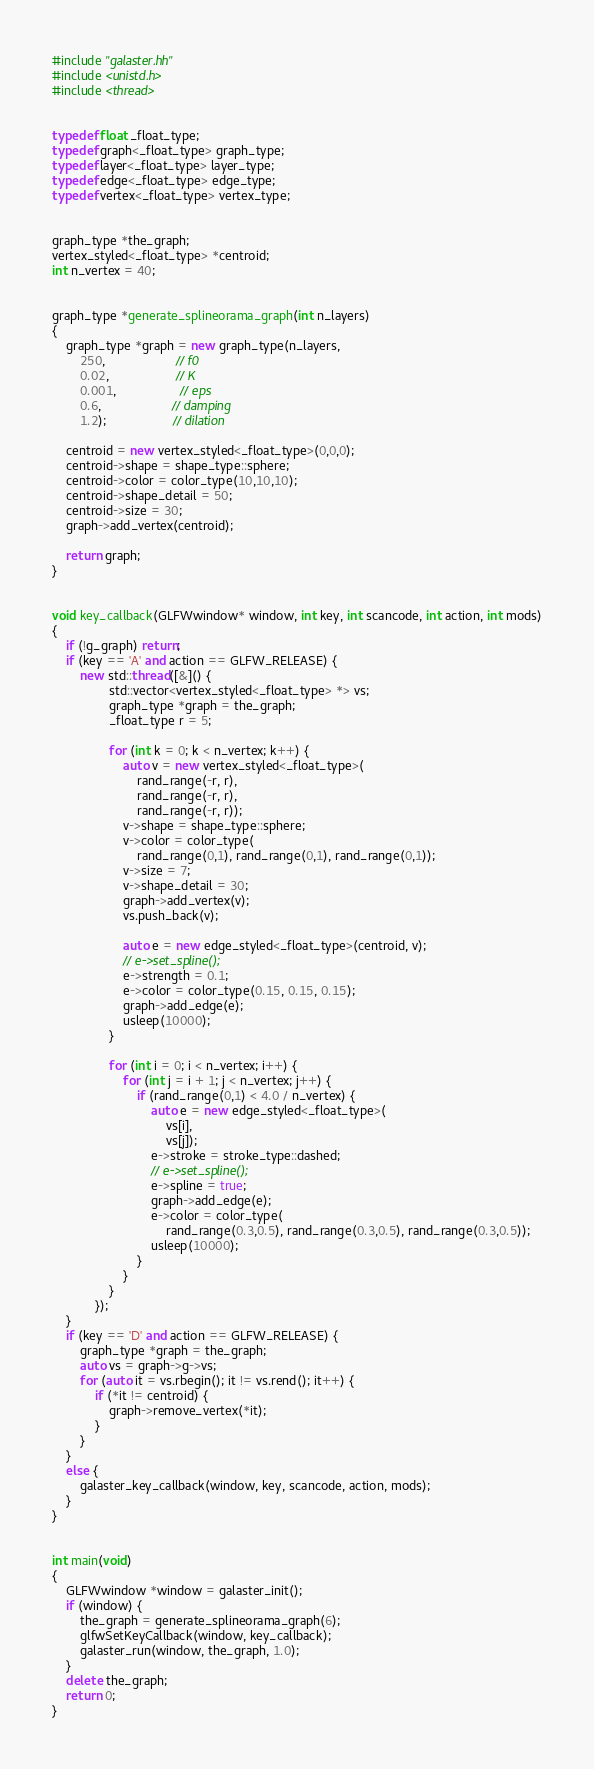<code> <loc_0><loc_0><loc_500><loc_500><_C++_>#include "galaster.hh"
#include <unistd.h>
#include <thread>


typedef float _float_type;
typedef graph<_float_type> graph_type;
typedef layer<_float_type> layer_type;
typedef edge<_float_type> edge_type;
typedef vertex<_float_type> vertex_type;


graph_type *the_graph;
vertex_styled<_float_type> *centroid;
int n_vertex = 40;


graph_type *generate_splineorama_graph(int n_layers)
{
    graph_type *graph = new graph_type(n_layers, 
        250,                    // f0
        0.02,                   // K
        0.001,                  // eps
        0.6,                    // damping
        1.2);                   // dilation

    centroid = new vertex_styled<_float_type>(0,0,0);
    centroid->shape = shape_type::sphere;
    centroid->color = color_type(10,10,10);
    centroid->shape_detail = 50;
    centroid->size = 30;
    graph->add_vertex(centroid);
    
    return graph;
}


void key_callback(GLFWwindow* window, int key, int scancode, int action, int mods)
{
    if (!g_graph) return;
    if (key == 'A' and action == GLFW_RELEASE) {
        new std::thread([&]() {
                std::vector<vertex_styled<_float_type> *> vs;
                graph_type *graph = the_graph;
                _float_type r = 5;

                for (int k = 0; k < n_vertex; k++) {
                    auto v = new vertex_styled<_float_type>(
                        rand_range(-r, r),
                        rand_range(-r, r),
                        rand_range(-r, r));
                    v->shape = shape_type::sphere;
                    v->color = color_type(
                        rand_range(0,1), rand_range(0,1), rand_range(0,1));
                    v->size = 7;
                    v->shape_detail = 30;
                    graph->add_vertex(v);
                    vs.push_back(v);

                    auto e = new edge_styled<_float_type>(centroid, v);
                    // e->set_spline();
                    e->strength = 0.1;
                    e->color = color_type(0.15, 0.15, 0.15);
                    graph->add_edge(e);
                    usleep(10000);
                }

                for (int i = 0; i < n_vertex; i++) {
                    for (int j = i + 1; j < n_vertex; j++) {
                        if (rand_range(0,1) < 4.0 / n_vertex) {
                            auto e = new edge_styled<_float_type>(
                                vs[i],
                                vs[j]);
                            e->stroke = stroke_type::dashed;
                            // e->set_spline();
                            e->spline = true;
                            graph->add_edge(e);
                            e->color = color_type(
                                rand_range(0.3,0.5), rand_range(0.3,0.5), rand_range(0.3,0.5));
                            usleep(10000);
                        }
                    }
                }
            });
    }
    if (key == 'D' and action == GLFW_RELEASE) {
        graph_type *graph = the_graph;
        auto vs = graph->g->vs;
        for (auto it = vs.rbegin(); it != vs.rend(); it++) {
            if (*it != centroid) {
                graph->remove_vertex(*it);
            }
        }
    }
    else {
        galaster_key_callback(window, key, scancode, action, mods);
    }
}


int main(void)
{
    GLFWwindow *window = galaster_init();
    if (window) {
        the_graph = generate_splineorama_graph(6);
        glfwSetKeyCallback(window, key_callback);
        galaster_run(window, the_graph, 1.0);
    }
    delete the_graph;
    return 0;
}
</code> 